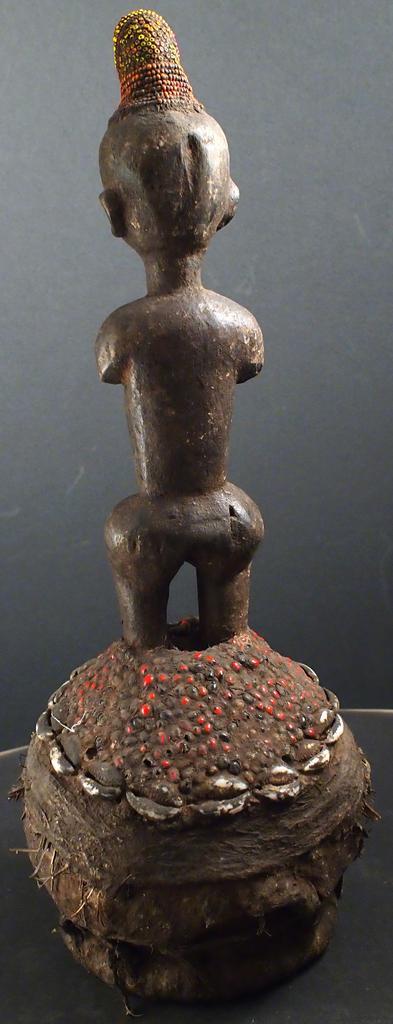In one or two sentences, can you explain what this image depicts? In this image we can see one statue on the surface. 